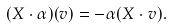Convert formula to latex. <formula><loc_0><loc_0><loc_500><loc_500>( X \cdot \alpha ) ( v ) = - \alpha ( X \cdot v ) .</formula> 